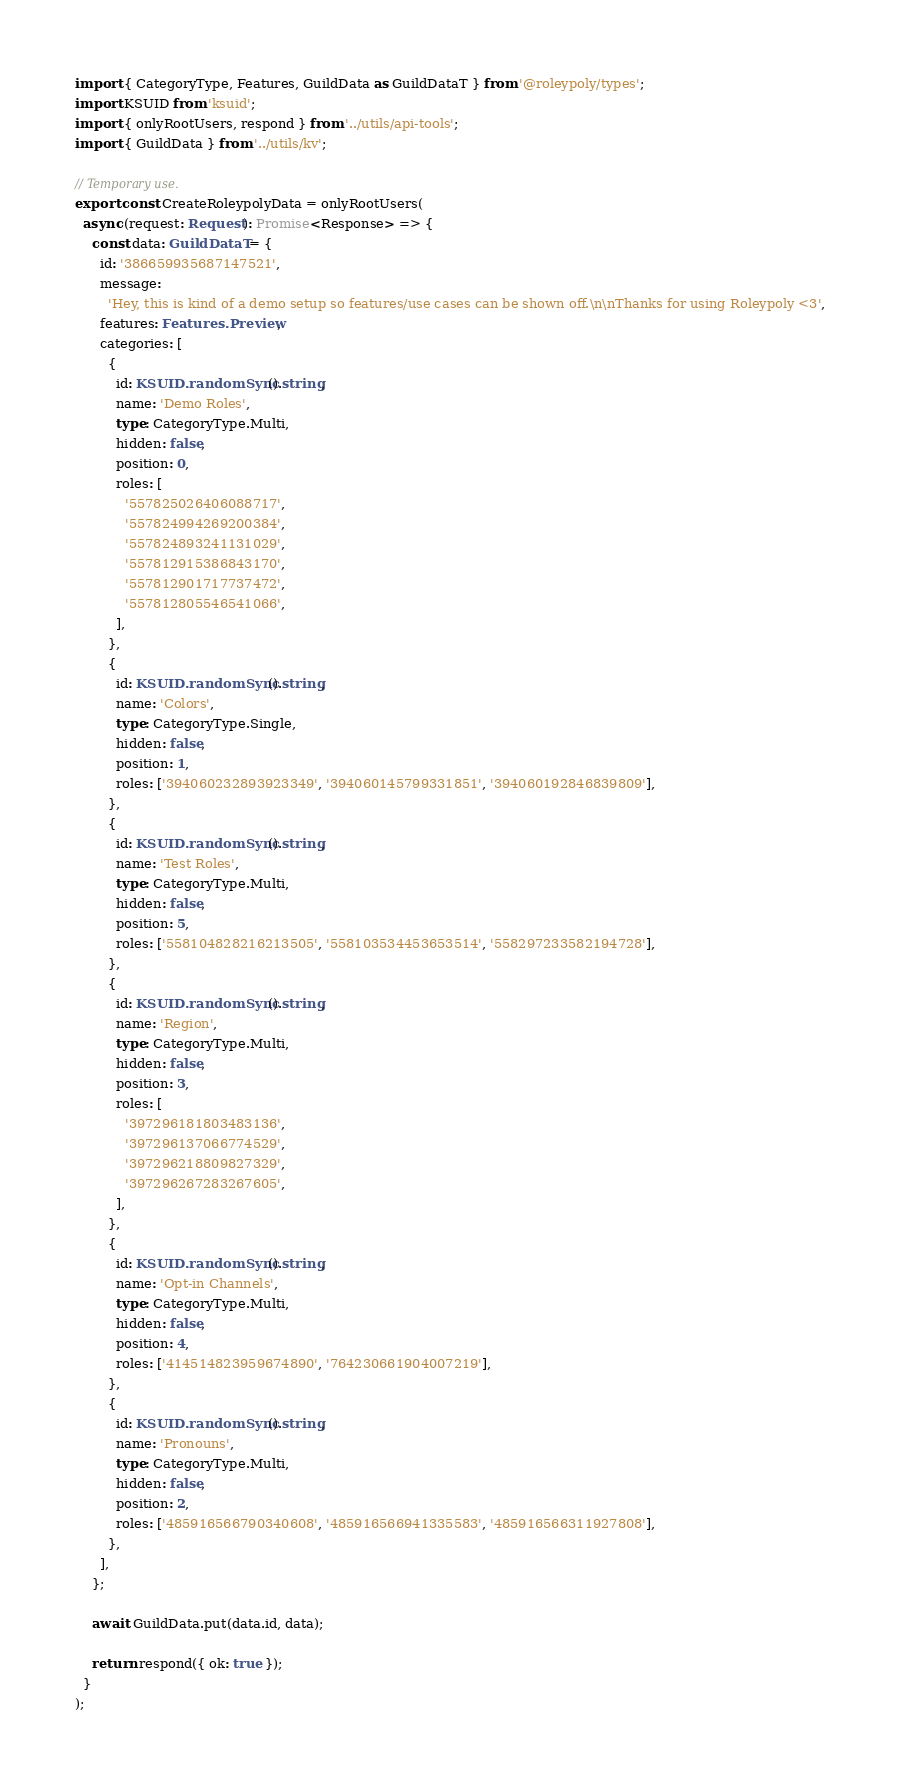<code> <loc_0><loc_0><loc_500><loc_500><_TypeScript_>import { CategoryType, Features, GuildData as GuildDataT } from '@roleypoly/types';
import KSUID from 'ksuid';
import { onlyRootUsers, respond } from '../utils/api-tools';
import { GuildData } from '../utils/kv';

// Temporary use.
export const CreateRoleypolyData = onlyRootUsers(
  async (request: Request): Promise<Response> => {
    const data: GuildDataT = {
      id: '386659935687147521',
      message:
        'Hey, this is kind of a demo setup so features/use cases can be shown off.\n\nThanks for using Roleypoly <3',
      features: Features.Preview,
      categories: [
        {
          id: KSUID.randomSync().string,
          name: 'Demo Roles',
          type: CategoryType.Multi,
          hidden: false,
          position: 0,
          roles: [
            '557825026406088717',
            '557824994269200384',
            '557824893241131029',
            '557812915386843170',
            '557812901717737472',
            '557812805546541066',
          ],
        },
        {
          id: KSUID.randomSync().string,
          name: 'Colors',
          type: CategoryType.Single,
          hidden: false,
          position: 1,
          roles: ['394060232893923349', '394060145799331851', '394060192846839809'],
        },
        {
          id: KSUID.randomSync().string,
          name: 'Test Roles',
          type: CategoryType.Multi,
          hidden: false,
          position: 5,
          roles: ['558104828216213505', '558103534453653514', '558297233582194728'],
        },
        {
          id: KSUID.randomSync().string,
          name: 'Region',
          type: CategoryType.Multi,
          hidden: false,
          position: 3,
          roles: [
            '397296181803483136',
            '397296137066774529',
            '397296218809827329',
            '397296267283267605',
          ],
        },
        {
          id: KSUID.randomSync().string,
          name: 'Opt-in Channels',
          type: CategoryType.Multi,
          hidden: false,
          position: 4,
          roles: ['414514823959674890', '764230661904007219'],
        },
        {
          id: KSUID.randomSync().string,
          name: 'Pronouns',
          type: CategoryType.Multi,
          hidden: false,
          position: 2,
          roles: ['485916566790340608', '485916566941335583', '485916566311927808'],
        },
      ],
    };

    await GuildData.put(data.id, data);

    return respond({ ok: true });
  }
);
</code> 